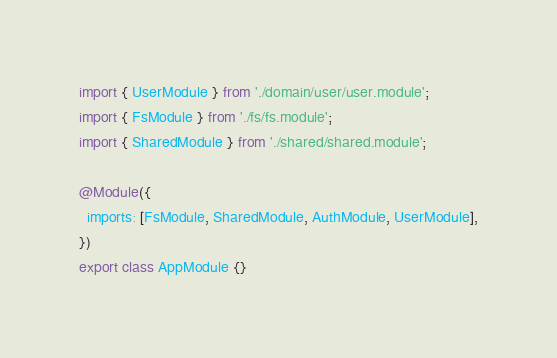Convert code to text. <code><loc_0><loc_0><loc_500><loc_500><_TypeScript_>import { UserModule } from './domain/user/user.module';
import { FsModule } from './fs/fs.module';
import { SharedModule } from './shared/shared.module';

@Module({
  imports: [FsModule, SharedModule, AuthModule, UserModule],
})
export class AppModule {}
</code> 